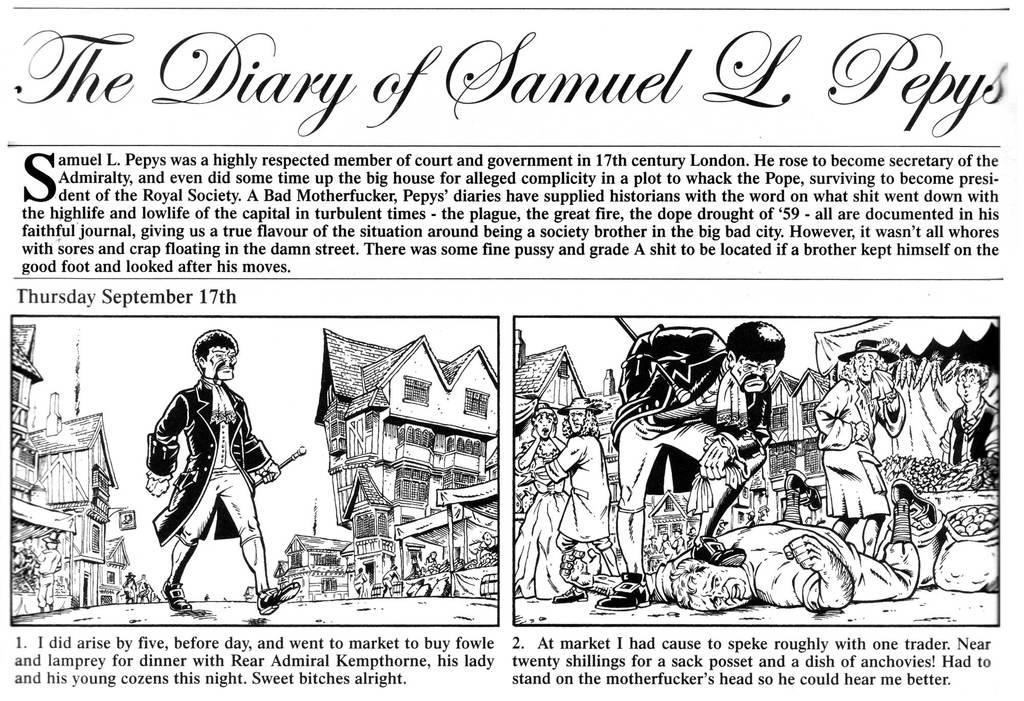How would you summarize this image in a sentence or two? This picture shows a newspaper with some cartoon pictures and we see text on it. 